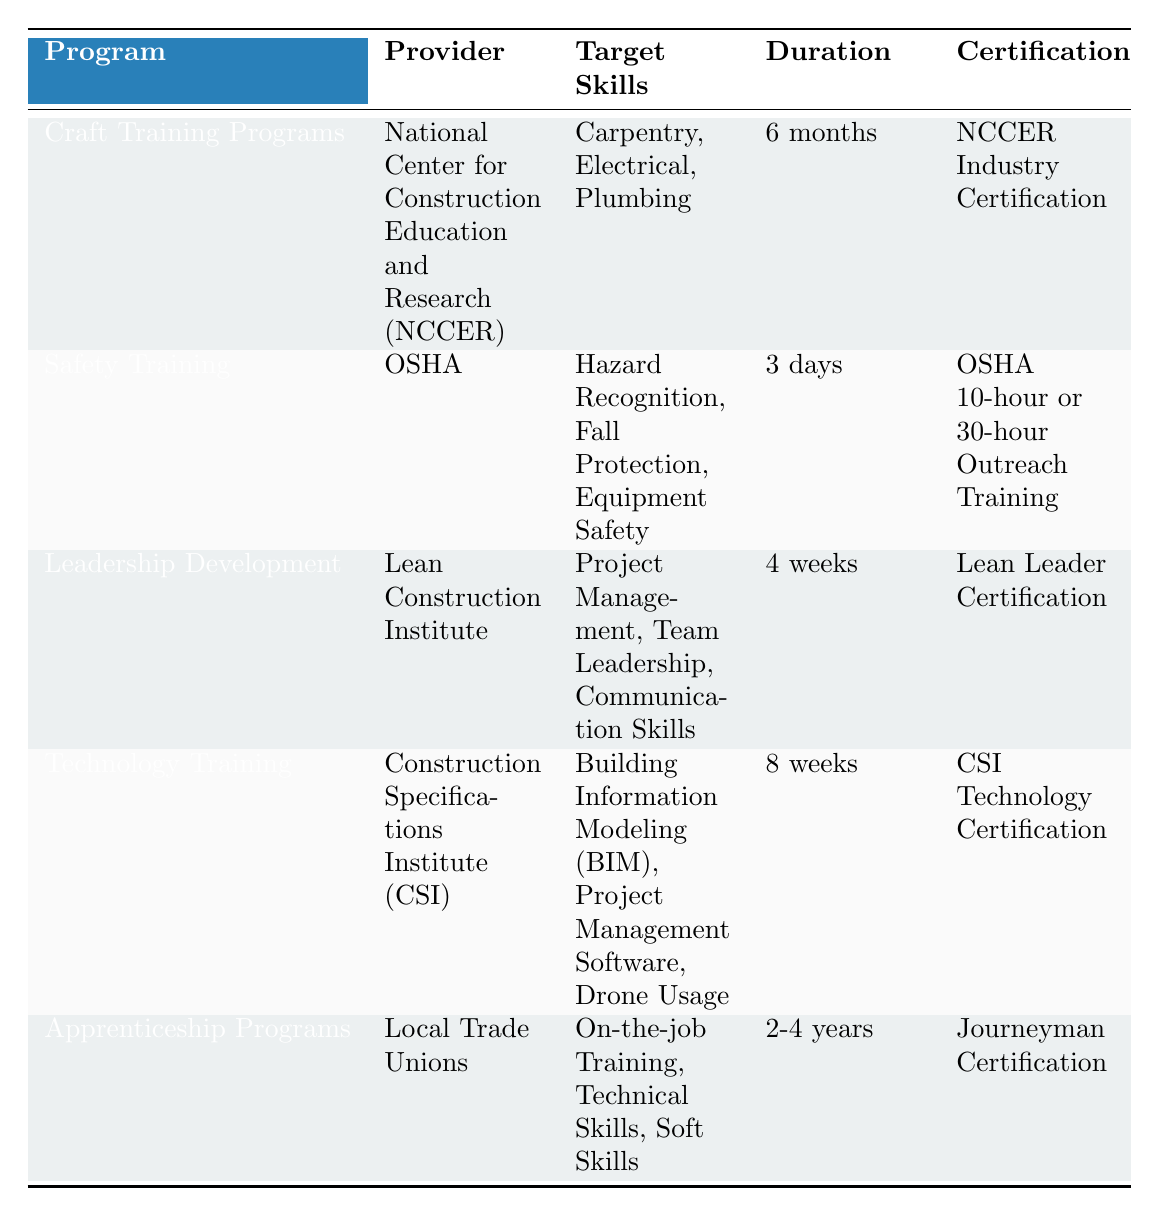What is the duration of the Craft Training Programs? The table shows that the duration of the Craft Training Programs is listed under the "Duration" column as "6 months."
Answer: 6 months Which program offers training in Hazard Recognition? According to the table, "Safety Training" is the program that includes Hazard Recognition among its target skills.
Answer: Safety Training Is there a program that lasts longer than 2 years? The Apprenticeship Programs are the only ones listed, with a duration of "2-4 years," making it true that there is a program lasting longer than 2 years.
Answer: Yes What are the target skills for the Technology Training program? The target skills for the Technology Training program are listed as "Building Information Modeling (BIM), Project Management Software, Drone Usage" in the corresponding row of the table.
Answer: Building Information Modeling (BIM), Project Management Software, Drone Usage Which program has the shortest duration of training? By reviewing the durations, Safety Training has the shortest duration listed, which is "3 days," compared to other programs.
Answer: Safety Training How many skills are taught in the Leadership Development program? The Leadership Development program lists three target skills: Project Management, Team Leadership, and Communication Skills. Therefore, the total number of skills is three.
Answer: 3 Which provider offers apprenticeship programs? The table specifies that Apprenticeship Programs are provided by Local Trade Unions.
Answer: Local Trade Unions What is the average duration of all the programs listed? The durations of the programs must be converted to a common unit for averaging: 6 months (0.5 years), 3 days (0.008 years), 4 weeks (approx. 0.08 years), 8 weeks (approx. 0.15 years), and 3 years (average of 2-4 years, approx. 3 years). Summing them gives 0.5 + 0.008 + 0.08 + 0.15 + 3 = 3.728. Dividing by 5 programs gives an average duration of approximately 0.746, which translates back to about 9 months.
Answer: 9 months Which certification is associated with the Leadership Development program? The certification for the Leadership Development program listed in the table is "Lean Leader Certification."
Answer: Lean Leader Certification 